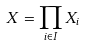<formula> <loc_0><loc_0><loc_500><loc_500>X = \prod _ { i \in I } X _ { i }</formula> 